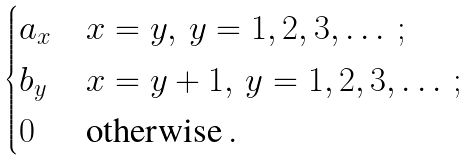<formula> <loc_0><loc_0><loc_500><loc_500>\begin{cases} a _ { x } & x = y , \, y = 1 , 2 , 3 , \dots \, ; \\ b _ { y } & x = y + 1 , \, y = 1 , 2 , 3 , \dots \, ; \\ 0 & \text {otherwise} \, . \end{cases}</formula> 